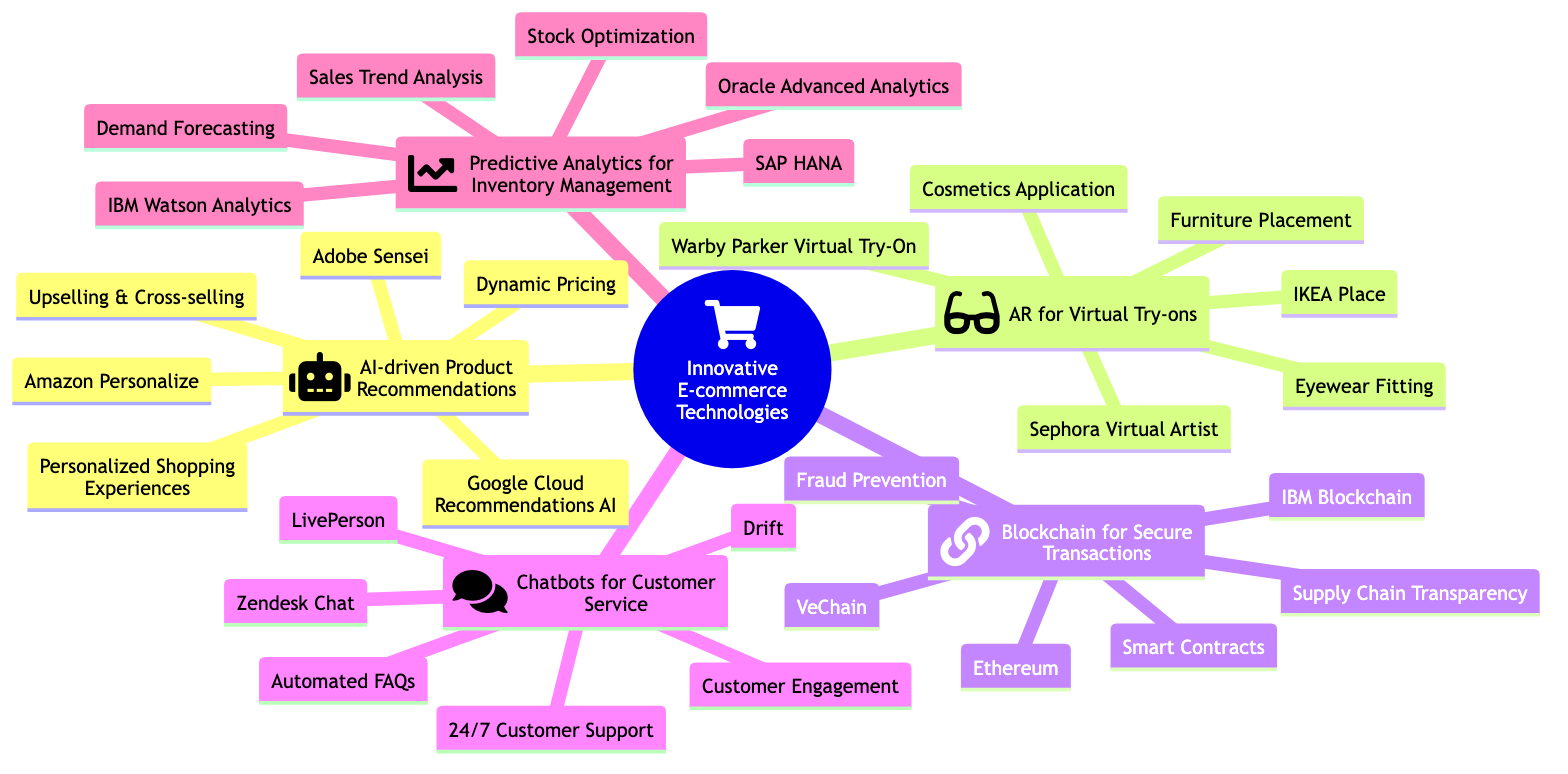What are the three applications of AI-driven Product Recommendations? The diagram lists three specific applications under AI-driven Product Recommendations: Personalized Shopping Experiences, Dynamic Pricing, and Upselling & Cross-selling. These can be observed directly beneath the "AI-driven Product Recommendations" node.
Answer: Personalized Shopping Experiences, Dynamic Pricing, Upselling & Cross-selling How many entities are listed under Blockchain for Secure Transactions? The "Blockchain for Secure Transactions" node contains three entities: IBM Blockchain, VeChain, and Ethereum. By counting the entities listed under this node, we find that there are three entities.
Answer: 3 Which technology includes "Furniture Placement" as an application? By examining the applications listed in the mind map, "Furniture Placement" is identified as an application under AR for Virtual Try-ons. This application is specifically linked to the use of AR technology in the furniture industry.
Answer: AR for Virtual Try-ons Name one chatbot platform mentioned in the diagram. In the section labeled "Chatbots for Customer Service," there are three platforms mentioned: Zendesk Chat, Drift, and LivePerson. Any of these can be considered an answer.
Answer: Zendesk Chat Which e-commerce technology is primarily aimed at "Fraud Prevention"? The application "Fraud Prevention" is explicitly linked to the "Blockchain for Secure Transactions" technology, which focuses on enhancing security in online transactions. Therefore, the answer is derived from this connection between the application and the technology.
Answer: Blockchain for Secure Transactions What is the main purpose of Predictive Analytics for Inventory Management? The primary objective of Predictive Analytics for Inventory Management, as outlined in the diagram, encompasses several applications including Demand Forecasting, Stock Optimization, and Sales Trend Analysis. Hence, the main purpose can be referred to through these applications.
Answer: Demand Forecasting How many technologies are outlined in the mind map? Counting the main branches off the root node, there are five distinct technologies included in the mind map: AI-driven Product Recommendations, AR for Virtual Try-ons, Blockchain for Secure Transactions, Chatbots for Customer Service, and Predictive Analytics for Inventory Management.
Answer: 5 Which entities are associated with AR for Virtual Try-ons? Under the AR for Virtual Try-ons node, the entities listed are IKEA Place, Sephora Virtual Artist, and Warby Parker Virtual Try-On. These entities are mentioned directly as components of this technology.
Answer: IKEA Place, Sephora Virtual Artist, Warby Parker Virtual Try-On 